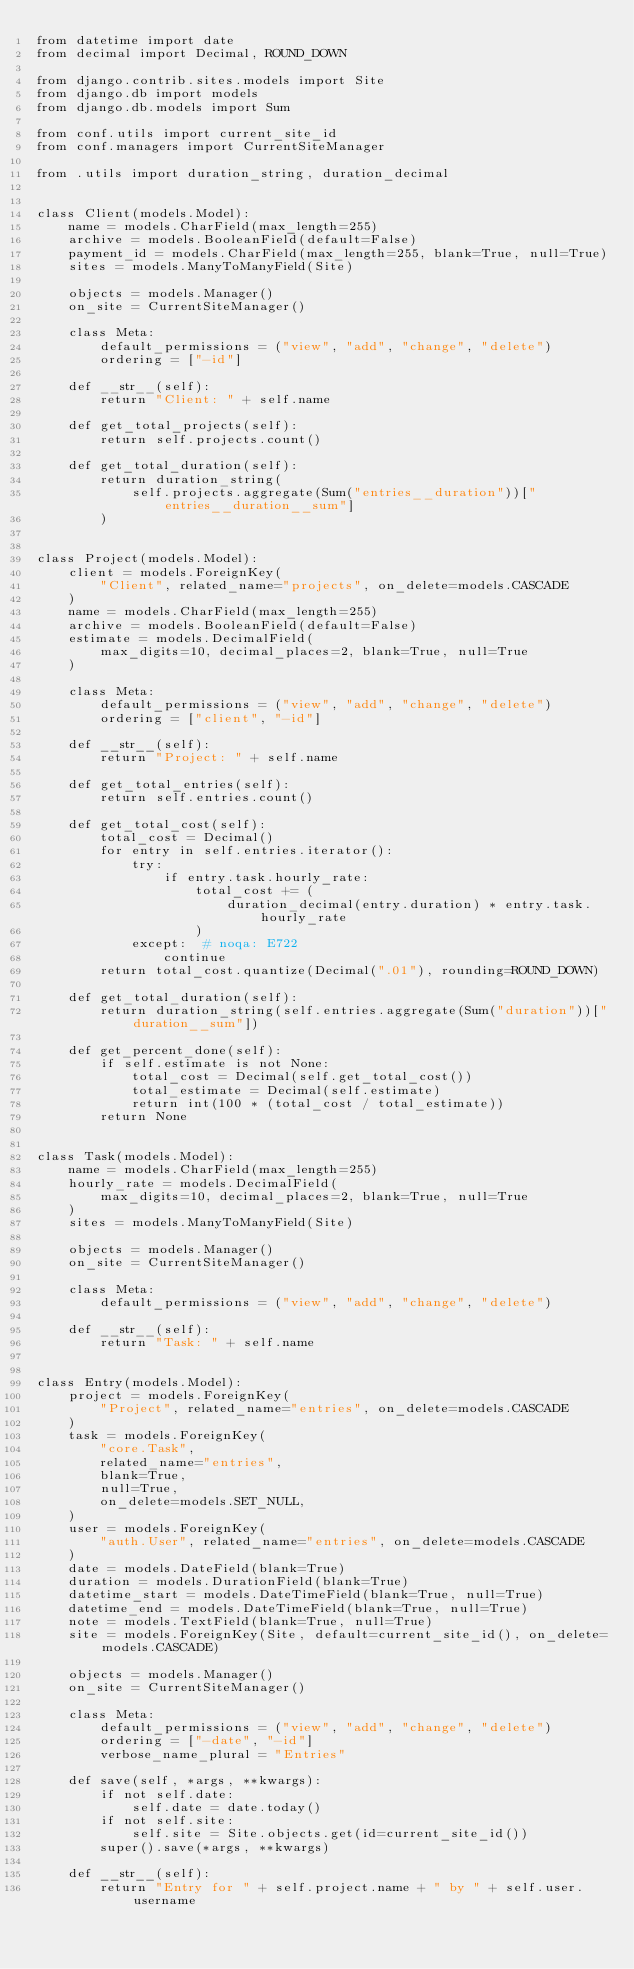Convert code to text. <code><loc_0><loc_0><loc_500><loc_500><_Python_>from datetime import date
from decimal import Decimal, ROUND_DOWN

from django.contrib.sites.models import Site
from django.db import models
from django.db.models import Sum

from conf.utils import current_site_id
from conf.managers import CurrentSiteManager

from .utils import duration_string, duration_decimal


class Client(models.Model):
    name = models.CharField(max_length=255)
    archive = models.BooleanField(default=False)
    payment_id = models.CharField(max_length=255, blank=True, null=True)
    sites = models.ManyToManyField(Site)

    objects = models.Manager()
    on_site = CurrentSiteManager()

    class Meta:
        default_permissions = ("view", "add", "change", "delete")
        ordering = ["-id"]

    def __str__(self):
        return "Client: " + self.name

    def get_total_projects(self):
        return self.projects.count()

    def get_total_duration(self):
        return duration_string(
            self.projects.aggregate(Sum("entries__duration"))["entries__duration__sum"]
        )


class Project(models.Model):
    client = models.ForeignKey(
        "Client", related_name="projects", on_delete=models.CASCADE
    )
    name = models.CharField(max_length=255)
    archive = models.BooleanField(default=False)
    estimate = models.DecimalField(
        max_digits=10, decimal_places=2, blank=True, null=True
    )

    class Meta:
        default_permissions = ("view", "add", "change", "delete")
        ordering = ["client", "-id"]

    def __str__(self):
        return "Project: " + self.name

    def get_total_entries(self):
        return self.entries.count()

    def get_total_cost(self):
        total_cost = Decimal()
        for entry in self.entries.iterator():
            try:
                if entry.task.hourly_rate:
                    total_cost += (
                        duration_decimal(entry.duration) * entry.task.hourly_rate
                    )
            except:  # noqa: E722
                continue
        return total_cost.quantize(Decimal(".01"), rounding=ROUND_DOWN)

    def get_total_duration(self):
        return duration_string(self.entries.aggregate(Sum("duration"))["duration__sum"])

    def get_percent_done(self):
        if self.estimate is not None:
            total_cost = Decimal(self.get_total_cost())
            total_estimate = Decimal(self.estimate)
            return int(100 * (total_cost / total_estimate))
        return None


class Task(models.Model):
    name = models.CharField(max_length=255)
    hourly_rate = models.DecimalField(
        max_digits=10, decimal_places=2, blank=True, null=True
    )
    sites = models.ManyToManyField(Site)

    objects = models.Manager()
    on_site = CurrentSiteManager()

    class Meta:
        default_permissions = ("view", "add", "change", "delete")

    def __str__(self):
        return "Task: " + self.name


class Entry(models.Model):
    project = models.ForeignKey(
        "Project", related_name="entries", on_delete=models.CASCADE
    )
    task = models.ForeignKey(
        "core.Task",
        related_name="entries",
        blank=True,
        null=True,
        on_delete=models.SET_NULL,
    )
    user = models.ForeignKey(
        "auth.User", related_name="entries", on_delete=models.CASCADE
    )
    date = models.DateField(blank=True)
    duration = models.DurationField(blank=True)
    datetime_start = models.DateTimeField(blank=True, null=True)
    datetime_end = models.DateTimeField(blank=True, null=True)
    note = models.TextField(blank=True, null=True)
    site = models.ForeignKey(Site, default=current_site_id(), on_delete=models.CASCADE)

    objects = models.Manager()
    on_site = CurrentSiteManager()

    class Meta:
        default_permissions = ("view", "add", "change", "delete")
        ordering = ["-date", "-id"]
        verbose_name_plural = "Entries"

    def save(self, *args, **kwargs):
        if not self.date:
            self.date = date.today()
        if not self.site:
            self.site = Site.objects.get(id=current_site_id())
        super().save(*args, **kwargs)

    def __str__(self):
        return "Entry for " + self.project.name + " by " + self.user.username
</code> 